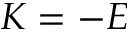<formula> <loc_0><loc_0><loc_500><loc_500>K = - E</formula> 